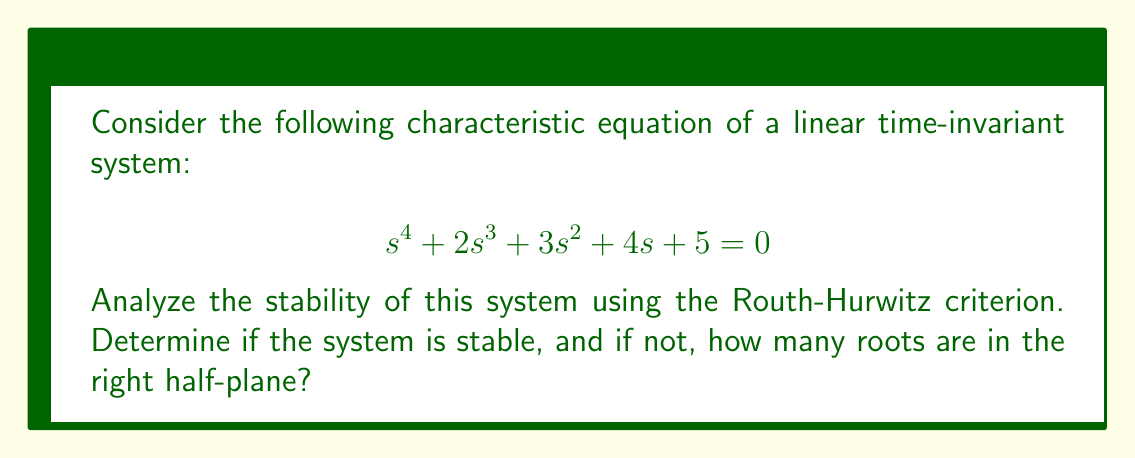Can you solve this math problem? To analyze the stability of the system using the Routh-Hurwitz criterion, we'll follow these steps:

1) First, let's construct the Routh array:

   $$ \begin{array}{c|cccc}
   s^4 & 1 & 3 & 5 \\
   s^3 & 2 & 4 & 0 \\
   s^2 & b_1 & b_2 & \\
   s^1 & c_1 & \\
   s^0 & d_1 &
   \end{array} $$

2) Calculate $b_1$:
   $$ b_1 = \frac{(2)(3) - (1)(4)}{2} = \frac{6-4}{2} = 1 $$

3) Calculate $b_2$:
   $$ b_2 = \frac{(2)(5) - (1)(0)}{2} = \frac{10}{2} = 5 $$

4) Calculate $c_1$:
   $$ c_1 = \frac{(1)(4) - (2)(5)}{1} = 4 - 10 = -6 $$

5) Calculate $d_1$:
   $$ d_1 = \frac{(-6)(5) - (1)(0)}{-6} = 5 $$

6) The complete Routh array:

   $$ \begin{array}{c|cccc}
   s^4 & 1 & 3 & 5 \\
   s^3 & 2 & 4 & 0 \\
   s^2 & 1 & 5 & \\
   s^1 & -6 & \\
   s^0 & 5 &
   \end{array} $$

7) Analyze the first column of the Routh array. The system is stable if and only if all elements in the first column have the same sign (all positive or all negative).

8) In this case, we see a sign change in the $s^1$ row, where we have -6.

9) The number of sign changes in the first column indicates the number of roots in the right half-plane. Here, we have one sign change.
Answer: The system is unstable, with 1 root in the right half-plane. 